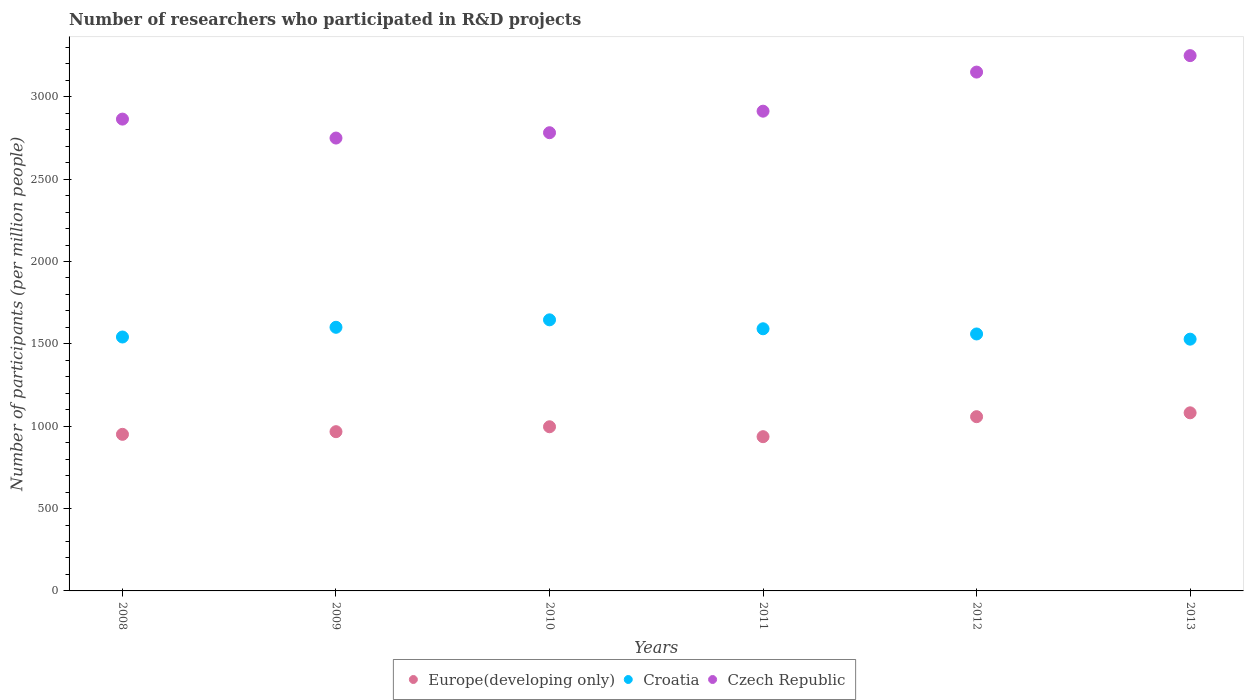How many different coloured dotlines are there?
Make the answer very short. 3. Is the number of dotlines equal to the number of legend labels?
Ensure brevity in your answer.  Yes. What is the number of researchers who participated in R&D projects in Croatia in 2013?
Keep it short and to the point. 1528.5. Across all years, what is the maximum number of researchers who participated in R&D projects in Czech Republic?
Offer a terse response. 3249.89. Across all years, what is the minimum number of researchers who participated in R&D projects in Europe(developing only)?
Keep it short and to the point. 936.45. In which year was the number of researchers who participated in R&D projects in Czech Republic maximum?
Make the answer very short. 2013. In which year was the number of researchers who participated in R&D projects in Czech Republic minimum?
Your response must be concise. 2009. What is the total number of researchers who participated in R&D projects in Croatia in the graph?
Provide a succinct answer. 9468.09. What is the difference between the number of researchers who participated in R&D projects in Czech Republic in 2009 and that in 2012?
Offer a terse response. -400.54. What is the difference between the number of researchers who participated in R&D projects in Croatia in 2011 and the number of researchers who participated in R&D projects in Czech Republic in 2008?
Provide a succinct answer. -1272.96. What is the average number of researchers who participated in R&D projects in Czech Republic per year?
Offer a very short reply. 2951.39. In the year 2011, what is the difference between the number of researchers who participated in R&D projects in Croatia and number of researchers who participated in R&D projects in Europe(developing only)?
Make the answer very short. 655.11. In how many years, is the number of researchers who participated in R&D projects in Europe(developing only) greater than 1100?
Ensure brevity in your answer.  0. What is the ratio of the number of researchers who participated in R&D projects in Europe(developing only) in 2008 to that in 2011?
Provide a succinct answer. 1.02. Is the number of researchers who participated in R&D projects in Europe(developing only) in 2010 less than that in 2013?
Make the answer very short. Yes. What is the difference between the highest and the second highest number of researchers who participated in R&D projects in Czech Republic?
Keep it short and to the point. 99.9. What is the difference between the highest and the lowest number of researchers who participated in R&D projects in Croatia?
Offer a terse response. 117.3. Is it the case that in every year, the sum of the number of researchers who participated in R&D projects in Europe(developing only) and number of researchers who participated in R&D projects in Croatia  is greater than the number of researchers who participated in R&D projects in Czech Republic?
Ensure brevity in your answer.  No. Is the number of researchers who participated in R&D projects in Europe(developing only) strictly greater than the number of researchers who participated in R&D projects in Croatia over the years?
Ensure brevity in your answer.  No. What is the title of the graph?
Your response must be concise. Number of researchers who participated in R&D projects. What is the label or title of the X-axis?
Keep it short and to the point. Years. What is the label or title of the Y-axis?
Give a very brief answer. Number of participants (per million people). What is the Number of participants (per million people) in Europe(developing only) in 2008?
Offer a terse response. 950.66. What is the Number of participants (per million people) in Croatia in 2008?
Your answer should be very brief. 1541.61. What is the Number of participants (per million people) in Czech Republic in 2008?
Your response must be concise. 2864.52. What is the Number of participants (per million people) of Europe(developing only) in 2009?
Your answer should be compact. 966.82. What is the Number of participants (per million people) in Croatia in 2009?
Offer a terse response. 1600.55. What is the Number of participants (per million people) in Czech Republic in 2009?
Your answer should be very brief. 2749.45. What is the Number of participants (per million people) in Europe(developing only) in 2010?
Provide a short and direct response. 996.64. What is the Number of participants (per million people) in Croatia in 2010?
Your answer should be very brief. 1645.81. What is the Number of participants (per million people) in Czech Republic in 2010?
Provide a succinct answer. 2781.85. What is the Number of participants (per million people) in Europe(developing only) in 2011?
Offer a terse response. 936.45. What is the Number of participants (per million people) of Croatia in 2011?
Make the answer very short. 1591.56. What is the Number of participants (per million people) in Czech Republic in 2011?
Offer a terse response. 2912.63. What is the Number of participants (per million people) of Europe(developing only) in 2012?
Ensure brevity in your answer.  1057.84. What is the Number of participants (per million people) of Croatia in 2012?
Provide a short and direct response. 1560.06. What is the Number of participants (per million people) in Czech Republic in 2012?
Provide a short and direct response. 3149.99. What is the Number of participants (per million people) in Europe(developing only) in 2013?
Provide a succinct answer. 1081.34. What is the Number of participants (per million people) in Croatia in 2013?
Provide a succinct answer. 1528.5. What is the Number of participants (per million people) of Czech Republic in 2013?
Ensure brevity in your answer.  3249.89. Across all years, what is the maximum Number of participants (per million people) of Europe(developing only)?
Offer a terse response. 1081.34. Across all years, what is the maximum Number of participants (per million people) of Croatia?
Provide a succinct answer. 1645.81. Across all years, what is the maximum Number of participants (per million people) of Czech Republic?
Provide a succinct answer. 3249.89. Across all years, what is the minimum Number of participants (per million people) of Europe(developing only)?
Keep it short and to the point. 936.45. Across all years, what is the minimum Number of participants (per million people) in Croatia?
Provide a short and direct response. 1528.5. Across all years, what is the minimum Number of participants (per million people) of Czech Republic?
Provide a succinct answer. 2749.45. What is the total Number of participants (per million people) of Europe(developing only) in the graph?
Provide a succinct answer. 5989.75. What is the total Number of participants (per million people) in Croatia in the graph?
Make the answer very short. 9468.09. What is the total Number of participants (per million people) of Czech Republic in the graph?
Make the answer very short. 1.77e+04. What is the difference between the Number of participants (per million people) of Europe(developing only) in 2008 and that in 2009?
Your response must be concise. -16.16. What is the difference between the Number of participants (per million people) of Croatia in 2008 and that in 2009?
Your answer should be compact. -58.93. What is the difference between the Number of participants (per million people) of Czech Republic in 2008 and that in 2009?
Your response must be concise. 115.07. What is the difference between the Number of participants (per million people) of Europe(developing only) in 2008 and that in 2010?
Offer a terse response. -45.98. What is the difference between the Number of participants (per million people) of Croatia in 2008 and that in 2010?
Offer a very short reply. -104.19. What is the difference between the Number of participants (per million people) of Czech Republic in 2008 and that in 2010?
Your answer should be compact. 82.66. What is the difference between the Number of participants (per million people) of Europe(developing only) in 2008 and that in 2011?
Give a very brief answer. 14.21. What is the difference between the Number of participants (per million people) of Croatia in 2008 and that in 2011?
Offer a terse response. -49.95. What is the difference between the Number of participants (per million people) of Czech Republic in 2008 and that in 2011?
Your answer should be very brief. -48.11. What is the difference between the Number of participants (per million people) in Europe(developing only) in 2008 and that in 2012?
Make the answer very short. -107.18. What is the difference between the Number of participants (per million people) of Croatia in 2008 and that in 2012?
Provide a short and direct response. -18.45. What is the difference between the Number of participants (per million people) in Czech Republic in 2008 and that in 2012?
Offer a terse response. -285.47. What is the difference between the Number of participants (per million people) in Europe(developing only) in 2008 and that in 2013?
Ensure brevity in your answer.  -130.68. What is the difference between the Number of participants (per million people) in Croatia in 2008 and that in 2013?
Keep it short and to the point. 13.11. What is the difference between the Number of participants (per million people) of Czech Republic in 2008 and that in 2013?
Ensure brevity in your answer.  -385.37. What is the difference between the Number of participants (per million people) in Europe(developing only) in 2009 and that in 2010?
Your response must be concise. -29.82. What is the difference between the Number of participants (per million people) of Croatia in 2009 and that in 2010?
Your answer should be compact. -45.26. What is the difference between the Number of participants (per million people) in Czech Republic in 2009 and that in 2010?
Offer a very short reply. -32.4. What is the difference between the Number of participants (per million people) of Europe(developing only) in 2009 and that in 2011?
Offer a terse response. 30.37. What is the difference between the Number of participants (per million people) in Croatia in 2009 and that in 2011?
Keep it short and to the point. 8.99. What is the difference between the Number of participants (per million people) in Czech Republic in 2009 and that in 2011?
Offer a very short reply. -163.18. What is the difference between the Number of participants (per million people) in Europe(developing only) in 2009 and that in 2012?
Offer a very short reply. -91.02. What is the difference between the Number of participants (per million people) in Croatia in 2009 and that in 2012?
Your response must be concise. 40.49. What is the difference between the Number of participants (per million people) of Czech Republic in 2009 and that in 2012?
Provide a short and direct response. -400.54. What is the difference between the Number of participants (per million people) of Europe(developing only) in 2009 and that in 2013?
Provide a succinct answer. -114.52. What is the difference between the Number of participants (per million people) in Croatia in 2009 and that in 2013?
Offer a very short reply. 72.04. What is the difference between the Number of participants (per million people) of Czech Republic in 2009 and that in 2013?
Your response must be concise. -500.44. What is the difference between the Number of participants (per million people) in Europe(developing only) in 2010 and that in 2011?
Provide a short and direct response. 60.19. What is the difference between the Number of participants (per million people) of Croatia in 2010 and that in 2011?
Offer a very short reply. 54.25. What is the difference between the Number of participants (per million people) in Czech Republic in 2010 and that in 2011?
Provide a succinct answer. -130.77. What is the difference between the Number of participants (per million people) of Europe(developing only) in 2010 and that in 2012?
Offer a terse response. -61.2. What is the difference between the Number of participants (per million people) of Croatia in 2010 and that in 2012?
Offer a very short reply. 85.75. What is the difference between the Number of participants (per million people) in Czech Republic in 2010 and that in 2012?
Provide a succinct answer. -368.14. What is the difference between the Number of participants (per million people) of Europe(developing only) in 2010 and that in 2013?
Your response must be concise. -84.7. What is the difference between the Number of participants (per million people) in Croatia in 2010 and that in 2013?
Provide a short and direct response. 117.3. What is the difference between the Number of participants (per million people) of Czech Republic in 2010 and that in 2013?
Your response must be concise. -468.04. What is the difference between the Number of participants (per million people) in Europe(developing only) in 2011 and that in 2012?
Ensure brevity in your answer.  -121.39. What is the difference between the Number of participants (per million people) of Croatia in 2011 and that in 2012?
Give a very brief answer. 31.5. What is the difference between the Number of participants (per million people) of Czech Republic in 2011 and that in 2012?
Keep it short and to the point. -237.36. What is the difference between the Number of participants (per million people) of Europe(developing only) in 2011 and that in 2013?
Your response must be concise. -144.89. What is the difference between the Number of participants (per million people) in Croatia in 2011 and that in 2013?
Offer a terse response. 63.05. What is the difference between the Number of participants (per million people) of Czech Republic in 2011 and that in 2013?
Your response must be concise. -337.26. What is the difference between the Number of participants (per million people) in Europe(developing only) in 2012 and that in 2013?
Provide a short and direct response. -23.49. What is the difference between the Number of participants (per million people) in Croatia in 2012 and that in 2013?
Provide a succinct answer. 31.56. What is the difference between the Number of participants (per million people) of Czech Republic in 2012 and that in 2013?
Your answer should be compact. -99.9. What is the difference between the Number of participants (per million people) of Europe(developing only) in 2008 and the Number of participants (per million people) of Croatia in 2009?
Your answer should be very brief. -649.89. What is the difference between the Number of participants (per million people) in Europe(developing only) in 2008 and the Number of participants (per million people) in Czech Republic in 2009?
Offer a very short reply. -1798.79. What is the difference between the Number of participants (per million people) in Croatia in 2008 and the Number of participants (per million people) in Czech Republic in 2009?
Offer a terse response. -1207.84. What is the difference between the Number of participants (per million people) of Europe(developing only) in 2008 and the Number of participants (per million people) of Croatia in 2010?
Offer a very short reply. -695.15. What is the difference between the Number of participants (per million people) of Europe(developing only) in 2008 and the Number of participants (per million people) of Czech Republic in 2010?
Make the answer very short. -1831.2. What is the difference between the Number of participants (per million people) in Croatia in 2008 and the Number of participants (per million people) in Czech Republic in 2010?
Your response must be concise. -1240.24. What is the difference between the Number of participants (per million people) in Europe(developing only) in 2008 and the Number of participants (per million people) in Croatia in 2011?
Provide a short and direct response. -640.9. What is the difference between the Number of participants (per million people) in Europe(developing only) in 2008 and the Number of participants (per million people) in Czech Republic in 2011?
Your answer should be compact. -1961.97. What is the difference between the Number of participants (per million people) in Croatia in 2008 and the Number of participants (per million people) in Czech Republic in 2011?
Ensure brevity in your answer.  -1371.02. What is the difference between the Number of participants (per million people) of Europe(developing only) in 2008 and the Number of participants (per million people) of Croatia in 2012?
Your answer should be compact. -609.4. What is the difference between the Number of participants (per million people) of Europe(developing only) in 2008 and the Number of participants (per million people) of Czech Republic in 2012?
Ensure brevity in your answer.  -2199.33. What is the difference between the Number of participants (per million people) of Croatia in 2008 and the Number of participants (per million people) of Czech Republic in 2012?
Provide a succinct answer. -1608.38. What is the difference between the Number of participants (per million people) of Europe(developing only) in 2008 and the Number of participants (per million people) of Croatia in 2013?
Make the answer very short. -577.85. What is the difference between the Number of participants (per million people) of Europe(developing only) in 2008 and the Number of participants (per million people) of Czech Republic in 2013?
Your response must be concise. -2299.23. What is the difference between the Number of participants (per million people) of Croatia in 2008 and the Number of participants (per million people) of Czech Republic in 2013?
Make the answer very short. -1708.28. What is the difference between the Number of participants (per million people) in Europe(developing only) in 2009 and the Number of participants (per million people) in Croatia in 2010?
Your answer should be compact. -678.99. What is the difference between the Number of participants (per million people) in Europe(developing only) in 2009 and the Number of participants (per million people) in Czech Republic in 2010?
Provide a short and direct response. -1815.04. What is the difference between the Number of participants (per million people) in Croatia in 2009 and the Number of participants (per million people) in Czech Republic in 2010?
Your answer should be very brief. -1181.31. What is the difference between the Number of participants (per million people) of Europe(developing only) in 2009 and the Number of participants (per million people) of Croatia in 2011?
Give a very brief answer. -624.74. What is the difference between the Number of participants (per million people) in Europe(developing only) in 2009 and the Number of participants (per million people) in Czech Republic in 2011?
Ensure brevity in your answer.  -1945.81. What is the difference between the Number of participants (per million people) in Croatia in 2009 and the Number of participants (per million people) in Czech Republic in 2011?
Give a very brief answer. -1312.08. What is the difference between the Number of participants (per million people) of Europe(developing only) in 2009 and the Number of participants (per million people) of Croatia in 2012?
Provide a succinct answer. -593.24. What is the difference between the Number of participants (per million people) in Europe(developing only) in 2009 and the Number of participants (per million people) in Czech Republic in 2012?
Make the answer very short. -2183.17. What is the difference between the Number of participants (per million people) of Croatia in 2009 and the Number of participants (per million people) of Czech Republic in 2012?
Ensure brevity in your answer.  -1549.45. What is the difference between the Number of participants (per million people) of Europe(developing only) in 2009 and the Number of participants (per million people) of Croatia in 2013?
Offer a terse response. -561.68. What is the difference between the Number of participants (per million people) of Europe(developing only) in 2009 and the Number of participants (per million people) of Czech Republic in 2013?
Offer a very short reply. -2283.07. What is the difference between the Number of participants (per million people) of Croatia in 2009 and the Number of participants (per million people) of Czech Republic in 2013?
Provide a short and direct response. -1649.34. What is the difference between the Number of participants (per million people) in Europe(developing only) in 2010 and the Number of participants (per million people) in Croatia in 2011?
Give a very brief answer. -594.92. What is the difference between the Number of participants (per million people) of Europe(developing only) in 2010 and the Number of participants (per million people) of Czech Republic in 2011?
Ensure brevity in your answer.  -1915.99. What is the difference between the Number of participants (per million people) in Croatia in 2010 and the Number of participants (per million people) in Czech Republic in 2011?
Offer a very short reply. -1266.82. What is the difference between the Number of participants (per million people) of Europe(developing only) in 2010 and the Number of participants (per million people) of Croatia in 2012?
Keep it short and to the point. -563.42. What is the difference between the Number of participants (per million people) in Europe(developing only) in 2010 and the Number of participants (per million people) in Czech Republic in 2012?
Provide a succinct answer. -2153.35. What is the difference between the Number of participants (per million people) of Croatia in 2010 and the Number of participants (per million people) of Czech Republic in 2012?
Make the answer very short. -1504.19. What is the difference between the Number of participants (per million people) in Europe(developing only) in 2010 and the Number of participants (per million people) in Croatia in 2013?
Give a very brief answer. -531.86. What is the difference between the Number of participants (per million people) in Europe(developing only) in 2010 and the Number of participants (per million people) in Czech Republic in 2013?
Offer a terse response. -2253.25. What is the difference between the Number of participants (per million people) in Croatia in 2010 and the Number of participants (per million people) in Czech Republic in 2013?
Make the answer very short. -1604.08. What is the difference between the Number of participants (per million people) in Europe(developing only) in 2011 and the Number of participants (per million people) in Croatia in 2012?
Ensure brevity in your answer.  -623.61. What is the difference between the Number of participants (per million people) in Europe(developing only) in 2011 and the Number of participants (per million people) in Czech Republic in 2012?
Your response must be concise. -2213.54. What is the difference between the Number of participants (per million people) of Croatia in 2011 and the Number of participants (per million people) of Czech Republic in 2012?
Give a very brief answer. -1558.43. What is the difference between the Number of participants (per million people) of Europe(developing only) in 2011 and the Number of participants (per million people) of Croatia in 2013?
Offer a very short reply. -592.05. What is the difference between the Number of participants (per million people) of Europe(developing only) in 2011 and the Number of participants (per million people) of Czech Republic in 2013?
Your response must be concise. -2313.44. What is the difference between the Number of participants (per million people) of Croatia in 2011 and the Number of participants (per million people) of Czech Republic in 2013?
Give a very brief answer. -1658.33. What is the difference between the Number of participants (per million people) in Europe(developing only) in 2012 and the Number of participants (per million people) in Croatia in 2013?
Provide a short and direct response. -470.66. What is the difference between the Number of participants (per million people) in Europe(developing only) in 2012 and the Number of participants (per million people) in Czech Republic in 2013?
Offer a very short reply. -2192.05. What is the difference between the Number of participants (per million people) of Croatia in 2012 and the Number of participants (per million people) of Czech Republic in 2013?
Keep it short and to the point. -1689.83. What is the average Number of participants (per million people) in Europe(developing only) per year?
Give a very brief answer. 998.29. What is the average Number of participants (per million people) of Croatia per year?
Offer a very short reply. 1578.01. What is the average Number of participants (per million people) of Czech Republic per year?
Provide a short and direct response. 2951.39. In the year 2008, what is the difference between the Number of participants (per million people) in Europe(developing only) and Number of participants (per million people) in Croatia?
Provide a succinct answer. -590.96. In the year 2008, what is the difference between the Number of participants (per million people) in Europe(developing only) and Number of participants (per million people) in Czech Republic?
Give a very brief answer. -1913.86. In the year 2008, what is the difference between the Number of participants (per million people) of Croatia and Number of participants (per million people) of Czech Republic?
Offer a terse response. -1322.91. In the year 2009, what is the difference between the Number of participants (per million people) in Europe(developing only) and Number of participants (per million people) in Croatia?
Your answer should be compact. -633.73. In the year 2009, what is the difference between the Number of participants (per million people) of Europe(developing only) and Number of participants (per million people) of Czech Republic?
Provide a succinct answer. -1782.63. In the year 2009, what is the difference between the Number of participants (per million people) in Croatia and Number of participants (per million people) in Czech Republic?
Provide a short and direct response. -1148.9. In the year 2010, what is the difference between the Number of participants (per million people) in Europe(developing only) and Number of participants (per million people) in Croatia?
Offer a very short reply. -649.17. In the year 2010, what is the difference between the Number of participants (per million people) of Europe(developing only) and Number of participants (per million people) of Czech Republic?
Make the answer very short. -1785.21. In the year 2010, what is the difference between the Number of participants (per million people) in Croatia and Number of participants (per million people) in Czech Republic?
Ensure brevity in your answer.  -1136.05. In the year 2011, what is the difference between the Number of participants (per million people) of Europe(developing only) and Number of participants (per million people) of Croatia?
Provide a succinct answer. -655.11. In the year 2011, what is the difference between the Number of participants (per million people) of Europe(developing only) and Number of participants (per million people) of Czech Republic?
Your answer should be compact. -1976.18. In the year 2011, what is the difference between the Number of participants (per million people) of Croatia and Number of participants (per million people) of Czech Republic?
Make the answer very short. -1321.07. In the year 2012, what is the difference between the Number of participants (per million people) in Europe(developing only) and Number of participants (per million people) in Croatia?
Give a very brief answer. -502.22. In the year 2012, what is the difference between the Number of participants (per million people) in Europe(developing only) and Number of participants (per million people) in Czech Republic?
Your answer should be compact. -2092.15. In the year 2012, what is the difference between the Number of participants (per million people) in Croatia and Number of participants (per million people) in Czech Republic?
Offer a terse response. -1589.93. In the year 2013, what is the difference between the Number of participants (per million people) in Europe(developing only) and Number of participants (per million people) in Croatia?
Offer a very short reply. -447.17. In the year 2013, what is the difference between the Number of participants (per million people) of Europe(developing only) and Number of participants (per million people) of Czech Republic?
Provide a succinct answer. -2168.55. In the year 2013, what is the difference between the Number of participants (per million people) in Croatia and Number of participants (per million people) in Czech Republic?
Provide a succinct answer. -1721.39. What is the ratio of the Number of participants (per million people) of Europe(developing only) in 2008 to that in 2009?
Offer a terse response. 0.98. What is the ratio of the Number of participants (per million people) in Croatia in 2008 to that in 2009?
Provide a short and direct response. 0.96. What is the ratio of the Number of participants (per million people) in Czech Republic in 2008 to that in 2009?
Provide a succinct answer. 1.04. What is the ratio of the Number of participants (per million people) of Europe(developing only) in 2008 to that in 2010?
Keep it short and to the point. 0.95. What is the ratio of the Number of participants (per million people) of Croatia in 2008 to that in 2010?
Offer a terse response. 0.94. What is the ratio of the Number of participants (per million people) in Czech Republic in 2008 to that in 2010?
Give a very brief answer. 1.03. What is the ratio of the Number of participants (per million people) in Europe(developing only) in 2008 to that in 2011?
Your response must be concise. 1.02. What is the ratio of the Number of participants (per million people) of Croatia in 2008 to that in 2011?
Your answer should be compact. 0.97. What is the ratio of the Number of participants (per million people) of Czech Republic in 2008 to that in 2011?
Provide a short and direct response. 0.98. What is the ratio of the Number of participants (per million people) of Europe(developing only) in 2008 to that in 2012?
Your answer should be compact. 0.9. What is the ratio of the Number of participants (per million people) in Czech Republic in 2008 to that in 2012?
Provide a succinct answer. 0.91. What is the ratio of the Number of participants (per million people) in Europe(developing only) in 2008 to that in 2013?
Your answer should be compact. 0.88. What is the ratio of the Number of participants (per million people) in Croatia in 2008 to that in 2013?
Keep it short and to the point. 1.01. What is the ratio of the Number of participants (per million people) in Czech Republic in 2008 to that in 2013?
Offer a terse response. 0.88. What is the ratio of the Number of participants (per million people) in Europe(developing only) in 2009 to that in 2010?
Make the answer very short. 0.97. What is the ratio of the Number of participants (per million people) of Croatia in 2009 to that in 2010?
Your answer should be very brief. 0.97. What is the ratio of the Number of participants (per million people) of Czech Republic in 2009 to that in 2010?
Make the answer very short. 0.99. What is the ratio of the Number of participants (per million people) of Europe(developing only) in 2009 to that in 2011?
Provide a succinct answer. 1.03. What is the ratio of the Number of participants (per million people) in Croatia in 2009 to that in 2011?
Provide a short and direct response. 1.01. What is the ratio of the Number of participants (per million people) of Czech Republic in 2009 to that in 2011?
Ensure brevity in your answer.  0.94. What is the ratio of the Number of participants (per million people) in Europe(developing only) in 2009 to that in 2012?
Keep it short and to the point. 0.91. What is the ratio of the Number of participants (per million people) in Croatia in 2009 to that in 2012?
Provide a succinct answer. 1.03. What is the ratio of the Number of participants (per million people) in Czech Republic in 2009 to that in 2012?
Provide a succinct answer. 0.87. What is the ratio of the Number of participants (per million people) in Europe(developing only) in 2009 to that in 2013?
Your answer should be very brief. 0.89. What is the ratio of the Number of participants (per million people) of Croatia in 2009 to that in 2013?
Offer a terse response. 1.05. What is the ratio of the Number of participants (per million people) in Czech Republic in 2009 to that in 2013?
Offer a very short reply. 0.85. What is the ratio of the Number of participants (per million people) in Europe(developing only) in 2010 to that in 2011?
Your answer should be compact. 1.06. What is the ratio of the Number of participants (per million people) in Croatia in 2010 to that in 2011?
Keep it short and to the point. 1.03. What is the ratio of the Number of participants (per million people) in Czech Republic in 2010 to that in 2011?
Provide a succinct answer. 0.96. What is the ratio of the Number of participants (per million people) in Europe(developing only) in 2010 to that in 2012?
Offer a terse response. 0.94. What is the ratio of the Number of participants (per million people) of Croatia in 2010 to that in 2012?
Give a very brief answer. 1.05. What is the ratio of the Number of participants (per million people) of Czech Republic in 2010 to that in 2012?
Your answer should be very brief. 0.88. What is the ratio of the Number of participants (per million people) in Europe(developing only) in 2010 to that in 2013?
Give a very brief answer. 0.92. What is the ratio of the Number of participants (per million people) in Croatia in 2010 to that in 2013?
Ensure brevity in your answer.  1.08. What is the ratio of the Number of participants (per million people) in Czech Republic in 2010 to that in 2013?
Provide a succinct answer. 0.86. What is the ratio of the Number of participants (per million people) in Europe(developing only) in 2011 to that in 2012?
Your response must be concise. 0.89. What is the ratio of the Number of participants (per million people) in Croatia in 2011 to that in 2012?
Offer a very short reply. 1.02. What is the ratio of the Number of participants (per million people) in Czech Republic in 2011 to that in 2012?
Your response must be concise. 0.92. What is the ratio of the Number of participants (per million people) in Europe(developing only) in 2011 to that in 2013?
Provide a succinct answer. 0.87. What is the ratio of the Number of participants (per million people) in Croatia in 2011 to that in 2013?
Your response must be concise. 1.04. What is the ratio of the Number of participants (per million people) of Czech Republic in 2011 to that in 2013?
Keep it short and to the point. 0.9. What is the ratio of the Number of participants (per million people) in Europe(developing only) in 2012 to that in 2013?
Your answer should be compact. 0.98. What is the ratio of the Number of participants (per million people) of Croatia in 2012 to that in 2013?
Keep it short and to the point. 1.02. What is the ratio of the Number of participants (per million people) of Czech Republic in 2012 to that in 2013?
Offer a terse response. 0.97. What is the difference between the highest and the second highest Number of participants (per million people) in Europe(developing only)?
Your response must be concise. 23.49. What is the difference between the highest and the second highest Number of participants (per million people) in Croatia?
Provide a short and direct response. 45.26. What is the difference between the highest and the second highest Number of participants (per million people) in Czech Republic?
Your answer should be compact. 99.9. What is the difference between the highest and the lowest Number of participants (per million people) in Europe(developing only)?
Ensure brevity in your answer.  144.89. What is the difference between the highest and the lowest Number of participants (per million people) in Croatia?
Your response must be concise. 117.3. What is the difference between the highest and the lowest Number of participants (per million people) of Czech Republic?
Your response must be concise. 500.44. 